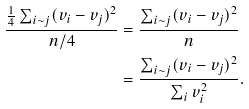Convert formula to latex. <formula><loc_0><loc_0><loc_500><loc_500>\frac { \frac { 1 } { 4 } \sum _ { i \sim j } ( v _ { i } - v _ { j } ) ^ { 2 } } { n / 4 } & = \frac { \sum _ { i \sim j } ( v _ { i } - v _ { j } ) ^ { 2 } } { n } \\ & = \frac { \sum _ { i \sim j } ( v _ { i } - v _ { j } ) ^ { 2 } } { \sum _ { i } v _ { i } ^ { 2 } } .</formula> 